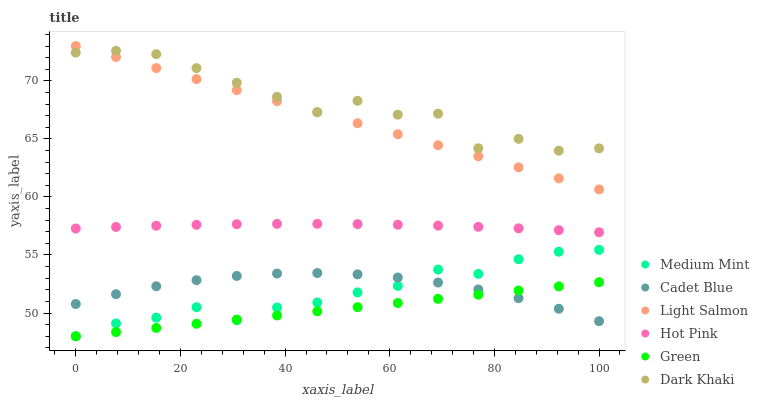Does Green have the minimum area under the curve?
Answer yes or no. Yes. Does Dark Khaki have the maximum area under the curve?
Answer yes or no. Yes. Does Light Salmon have the minimum area under the curve?
Answer yes or no. No. Does Light Salmon have the maximum area under the curve?
Answer yes or no. No. Is Green the smoothest?
Answer yes or no. Yes. Is Dark Khaki the roughest?
Answer yes or no. Yes. Is Light Salmon the smoothest?
Answer yes or no. No. Is Light Salmon the roughest?
Answer yes or no. No. Does Medium Mint have the lowest value?
Answer yes or no. Yes. Does Light Salmon have the lowest value?
Answer yes or no. No. Does Light Salmon have the highest value?
Answer yes or no. Yes. Does Cadet Blue have the highest value?
Answer yes or no. No. Is Medium Mint less than Hot Pink?
Answer yes or no. Yes. Is Hot Pink greater than Green?
Answer yes or no. Yes. Does Cadet Blue intersect Green?
Answer yes or no. Yes. Is Cadet Blue less than Green?
Answer yes or no. No. Is Cadet Blue greater than Green?
Answer yes or no. No. Does Medium Mint intersect Hot Pink?
Answer yes or no. No. 